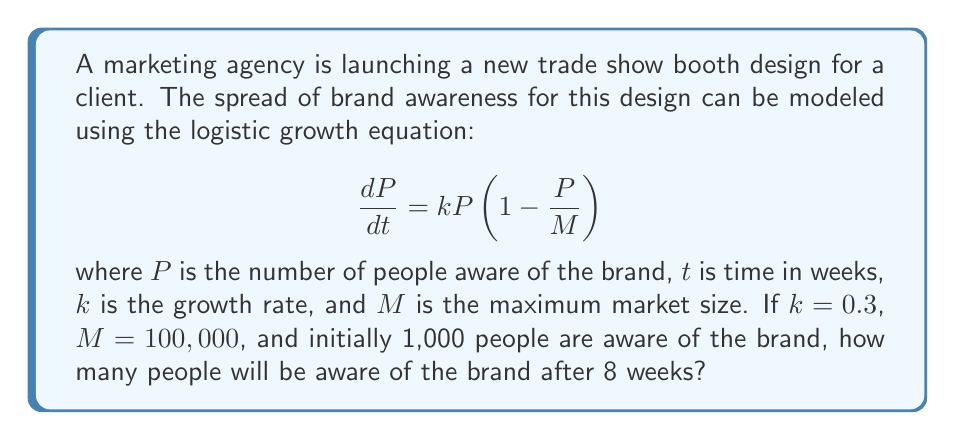Could you help me with this problem? To solve this problem, we need to use the solution to the logistic growth equation:

$$P(t) = \frac{M}{1 + (\frac{M}{P_0} - 1)e^{-kt}}$$

Where:
- $P(t)$ is the number of people aware of the brand at time $t$
- $M$ is the maximum market size (100,000)
- $P_0$ is the initial number of people aware of the brand (1,000)
- $k$ is the growth rate (0.3)
- $t$ is the time in weeks (8)

Let's substitute these values into the equation:

$$P(8) = \frac{100,000}{1 + (\frac{100,000}{1,000} - 1)e^{-0.3 \cdot 8}}$$

$$= \frac{100,000}{1 + (99)e^{-2.4}}$$

Now, let's calculate this step-by-step:

1. Calculate $e^{-2.4}$:
   $e^{-2.4} \approx 0.0907$

2. Multiply by 99:
   $99 \cdot 0.0907 \approx 8.9793$

3. Add 1:
   $1 + 8.9793 = 9.9793$

4. Divide 100,000 by this result:
   $\frac{100,000}{9.9793} \approx 10,020$

Therefore, after 8 weeks, approximately 10,020 people will be aware of the brand.
Answer: Approximately 10,020 people will be aware of the brand after 8 weeks. 